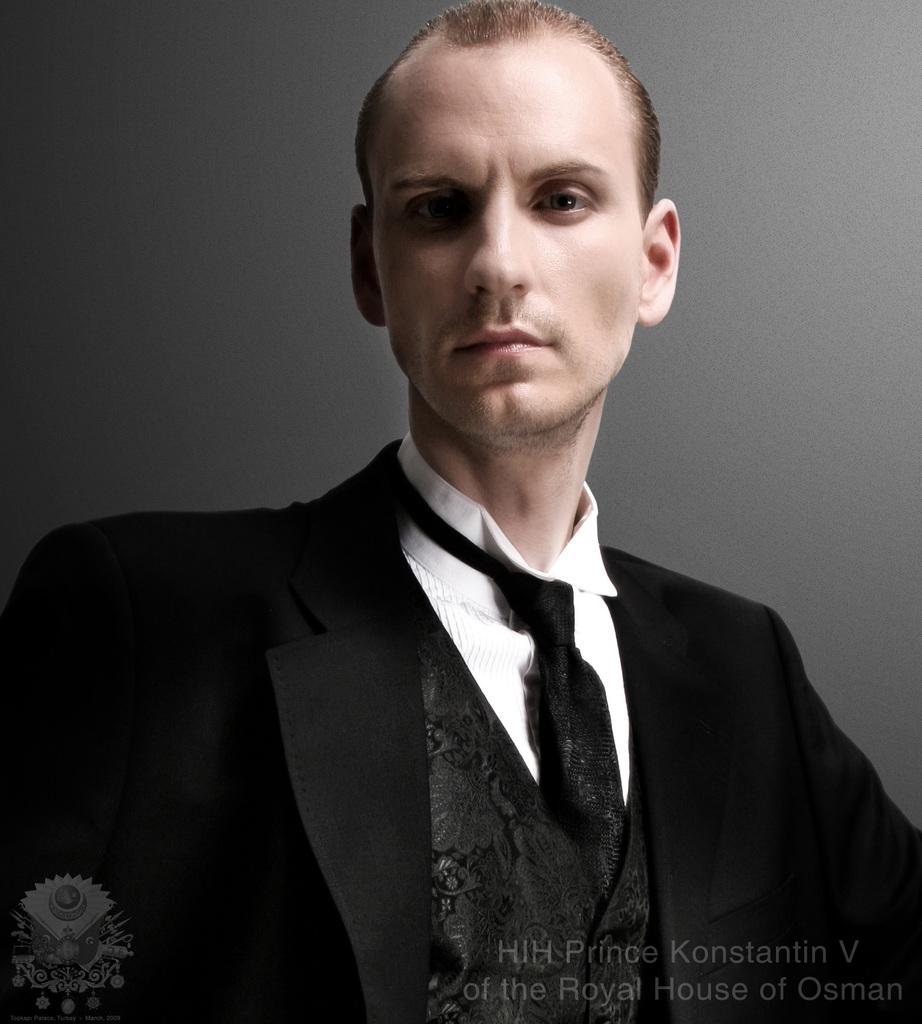Who or what is the main subject in the image? There is a person in the image. What is the person wearing? The person is wearing a black and white colored dress. What color is the background of the image? The background of the image is grey in color. How many centimeters is the person's brain visible in the image? There is no visible indication of the person's brain in the image, so it is not possible to determine its size in centimeters. 